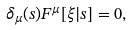<formula> <loc_0><loc_0><loc_500><loc_500>\delta _ { \mu } ( s ) F ^ { \mu } [ \xi | s ] = 0 ,</formula> 